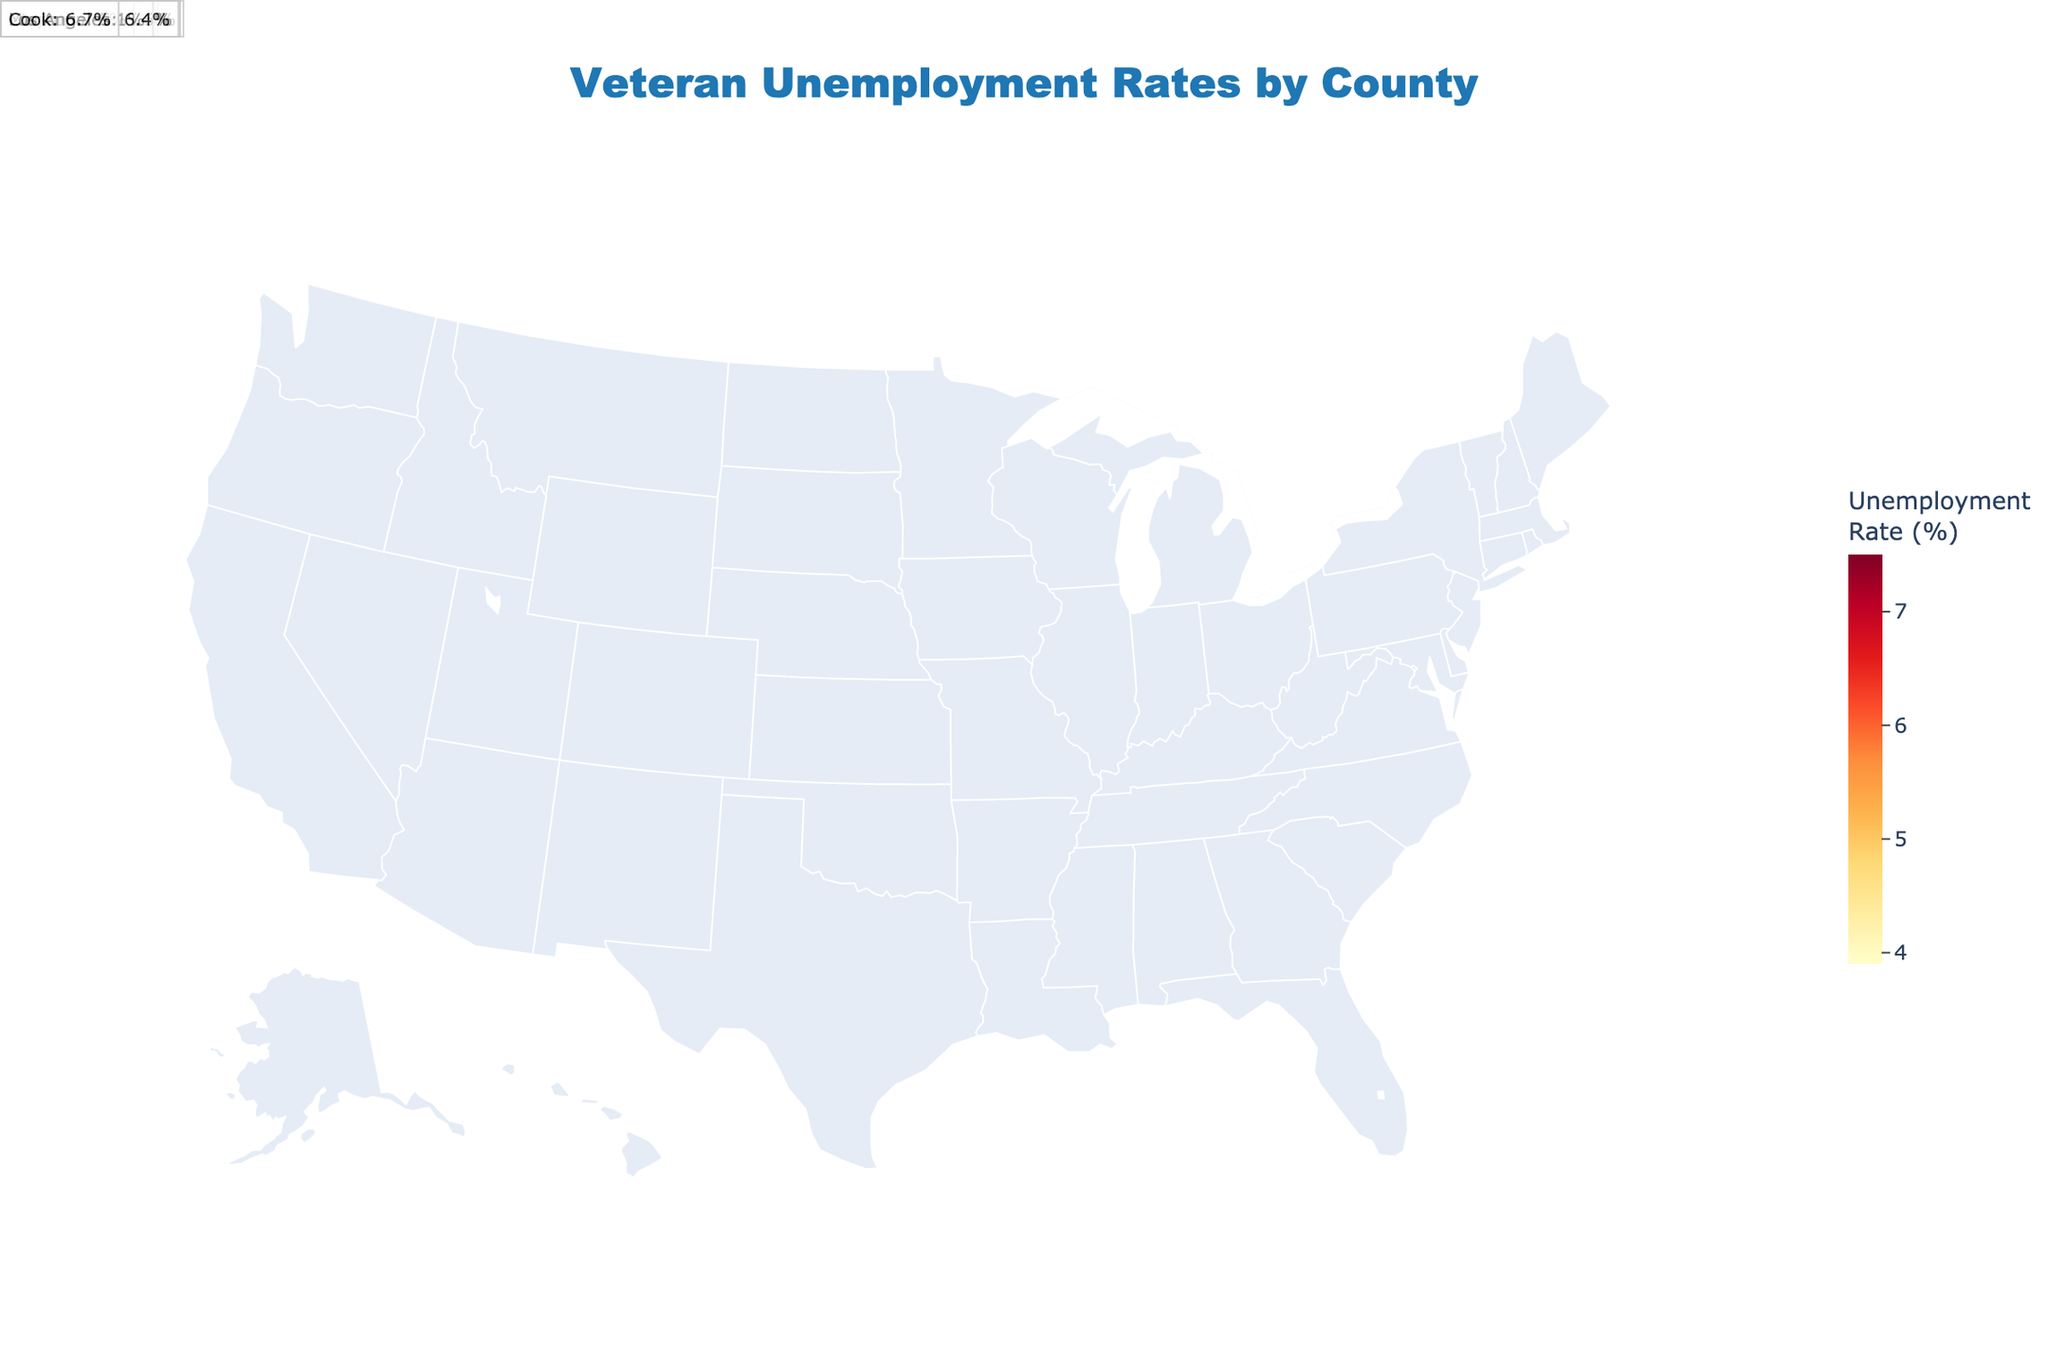What is the title of the figure? The title is usually placed at the top of the chart and is often larger and bolder than other text. In this heatmap, the title is "Veteran Unemployment Rates by County".
Answer: Veteran Unemployment Rates by County Which county has the lowest veteran unemployment rate according to the figure? To find the county with the lowest unemployment rate, scan the heatmap for the county with the lightest color, which represents the lowest rate. Fairfax, Virginia, has the lowest rate at 3.9%.
Answer: Fairfax, Virginia Which county has the highest veteran unemployment rate according to the figure? Scan the heatmap for the county with the darkest color, which represents the highest unemployment rate. Wayne, Michigan, has the highest rate at 7.5%.
Answer: Wayne, Michigan What's the average veteran unemployment rate of the counties shown in Texas? First, list the unemployment rates of the counties in Texas: Travis (4.8), Harris (5.3), San Antonio (5.6), and Bexar (5.8). Calculate the average: (4.8 + 5.3 + 5.6 + 5.8) / 4 = 5.375%.
Answer: 5.38% Compare the veteran unemployment rates of Los Angeles, California, and San Diego, California. Which one is higher? According to the figure, Los Angeles has a veteran unemployment rate of 6.4%, while San Diego has a rate of 5.2%. Therefore, Los Angeles has a higher rate.
Answer: Los Angeles, California How many counties have a veteran unemployment rate above 6%? Count the counties with an unemployment rate above 6%: Norfolk, Cumberland, Montgomery, Escambia, Los Angeles, Clark, Wayne, and Cook. This totals 8 counties.
Answer: 8 What is the median veteran unemployment rate for the counties listed in the figure? List all the unemployment rates in ascending order: 3.9, 4.1, 4.7, 4.8, 5.1, 5.2, 5.3, 5.5, 5.6, 5.7, 5.8, 5.9, 6.1, 6.2, 6.4, 6.5, 6.7, 6.8, 7.3, 7.5. The median is the middle value, so the rate at the 10th and 11th positions (5.7 + 5.8) / 2 = 5.75%.
Answer: 5.75% Which state has the largest regional variation in veteran unemployment rates according to this figure? Look for a state having multiple counties with significantly different unemployment rates. Virginia has Norfolk with 6.1% and Fairfax with 3.9%, a notable variation.
Answer: Virginia 